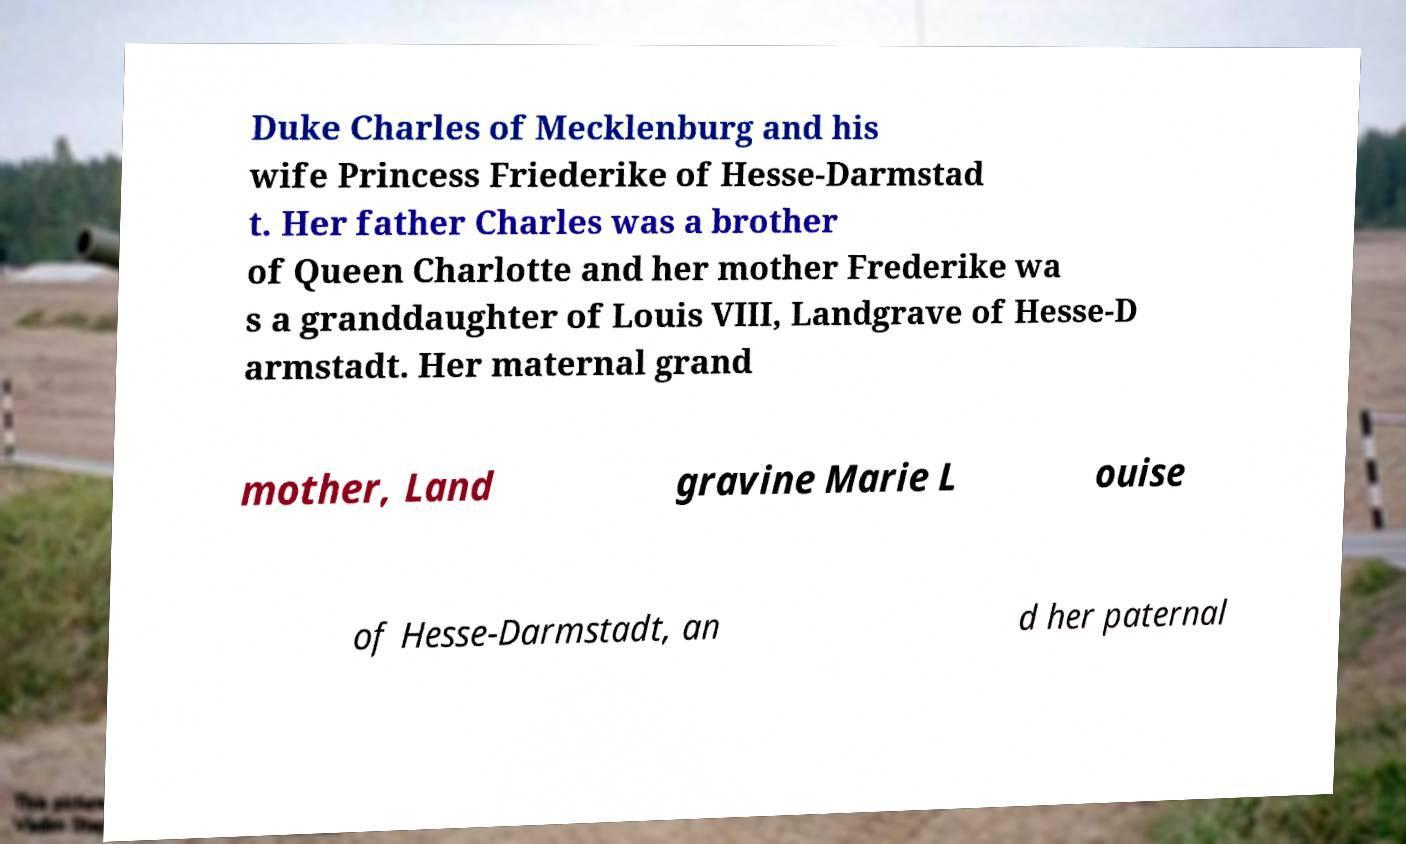I need the written content from this picture converted into text. Can you do that? Duke Charles of Mecklenburg and his wife Princess Friederike of Hesse-Darmstad t. Her father Charles was a brother of Queen Charlotte and her mother Frederike wa s a granddaughter of Louis VIII, Landgrave of Hesse-D armstadt. Her maternal grand mother, Land gravine Marie L ouise of Hesse-Darmstadt, an d her paternal 